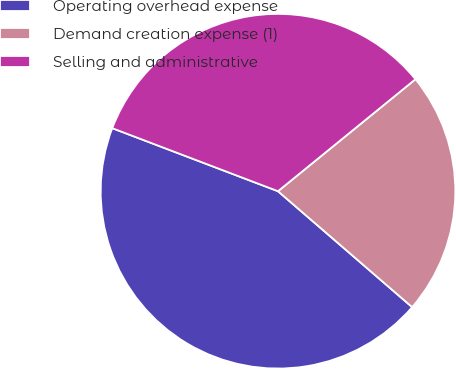<chart> <loc_0><loc_0><loc_500><loc_500><pie_chart><fcel>Operating overhead expense<fcel>Demand creation expense (1)<fcel>Selling and administrative<nl><fcel>44.44%<fcel>22.22%<fcel>33.33%<nl></chart> 